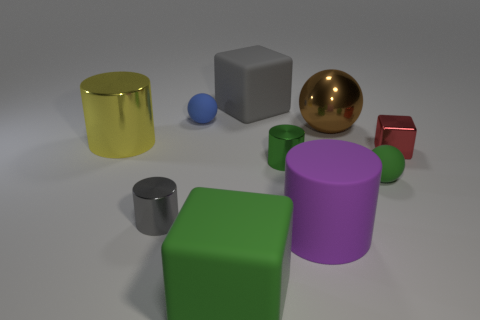Subtract 1 cylinders. How many cylinders are left? 3 Subtract all balls. How many objects are left? 7 Add 5 brown metallic spheres. How many brown metallic spheres exist? 6 Subtract 1 brown balls. How many objects are left? 9 Subtract all purple spheres. Subtract all purple things. How many objects are left? 9 Add 8 green rubber blocks. How many green rubber blocks are left? 9 